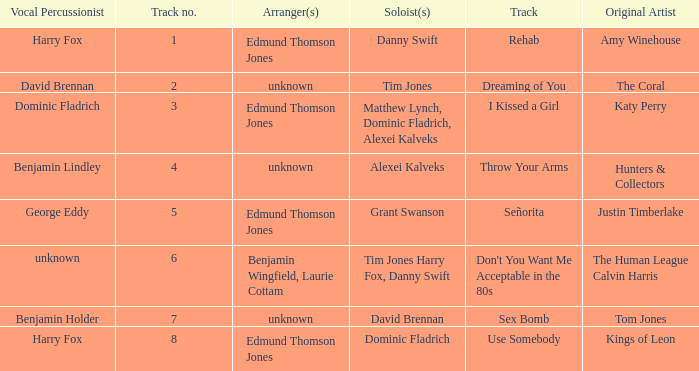Who is the original artist of "Use Somebody"? Kings of Leon. 